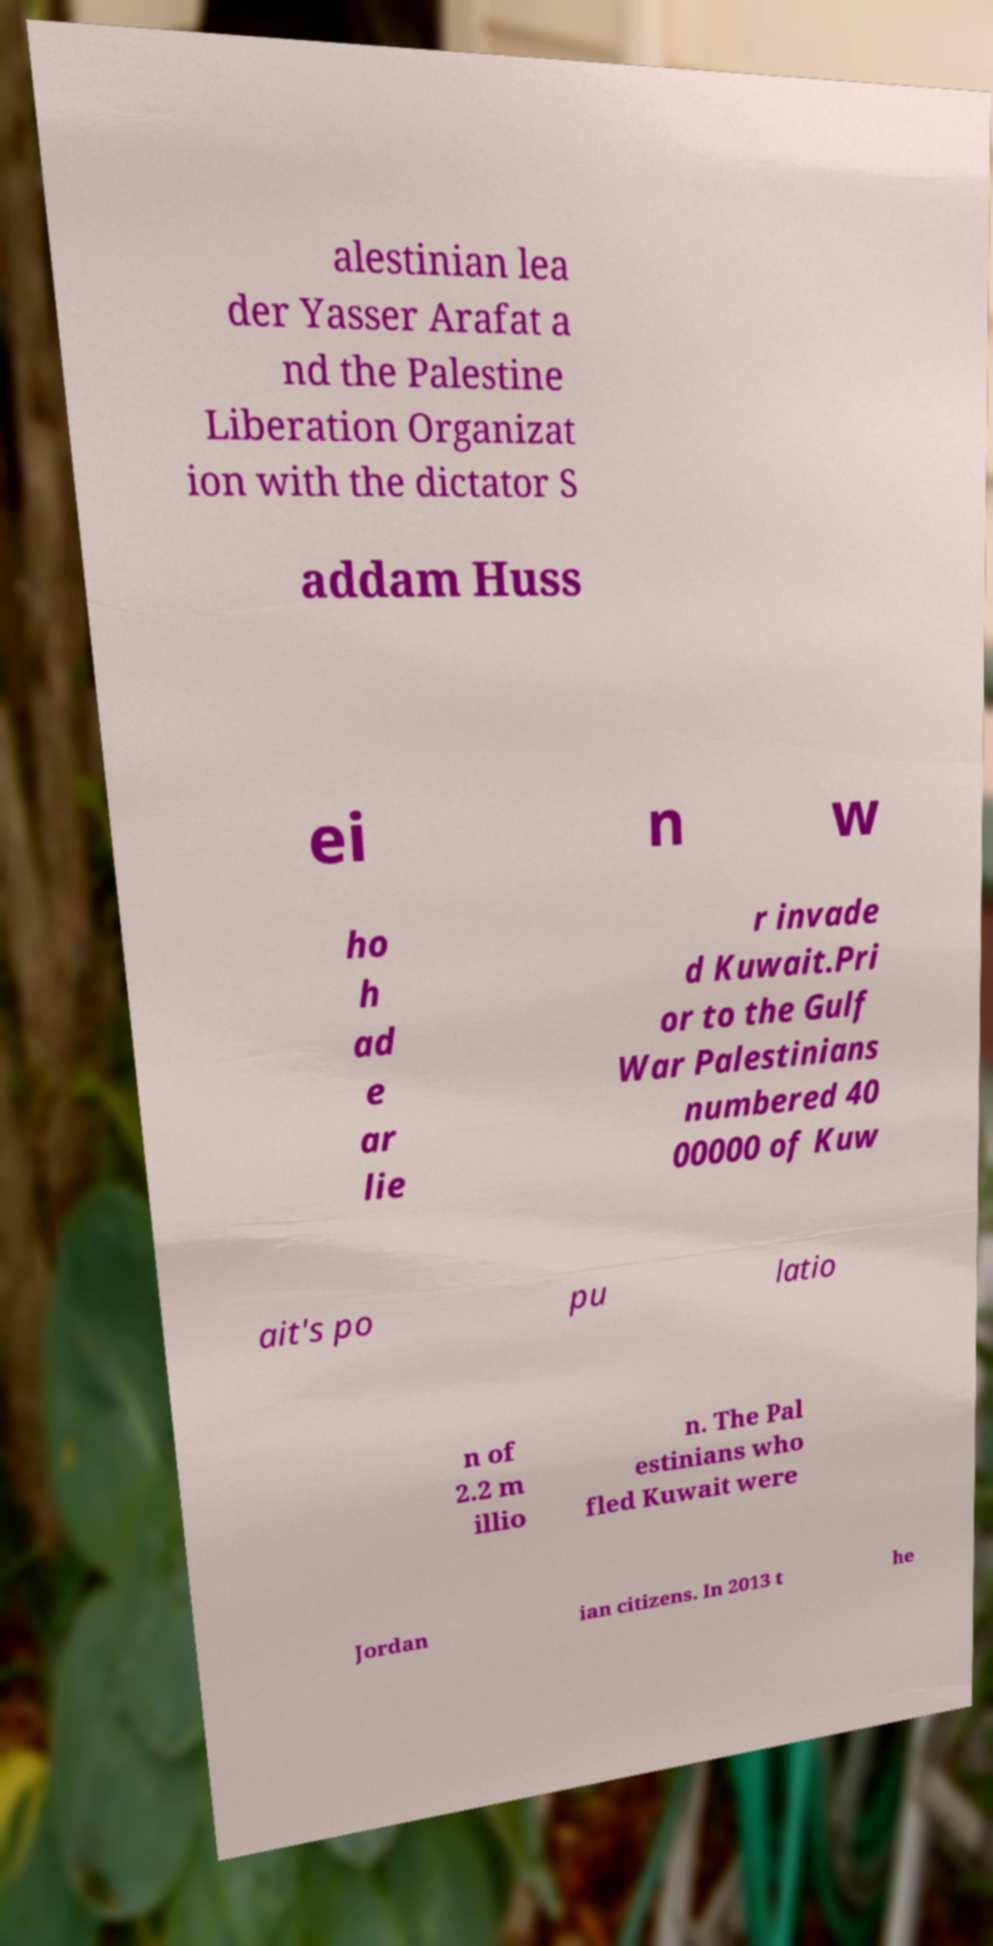There's text embedded in this image that I need extracted. Can you transcribe it verbatim? alestinian lea der Yasser Arafat a nd the Palestine Liberation Organizat ion with the dictator S addam Huss ei n w ho h ad e ar lie r invade d Kuwait.Pri or to the Gulf War Palestinians numbered 40 00000 of Kuw ait's po pu latio n of 2.2 m illio n. The Pal estinians who fled Kuwait were Jordan ian citizens. In 2013 t he 